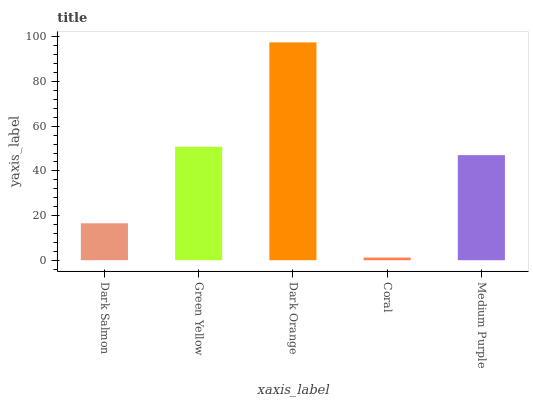Is Coral the minimum?
Answer yes or no. Yes. Is Dark Orange the maximum?
Answer yes or no. Yes. Is Green Yellow the minimum?
Answer yes or no. No. Is Green Yellow the maximum?
Answer yes or no. No. Is Green Yellow greater than Dark Salmon?
Answer yes or no. Yes. Is Dark Salmon less than Green Yellow?
Answer yes or no. Yes. Is Dark Salmon greater than Green Yellow?
Answer yes or no. No. Is Green Yellow less than Dark Salmon?
Answer yes or no. No. Is Medium Purple the high median?
Answer yes or no. Yes. Is Medium Purple the low median?
Answer yes or no. Yes. Is Dark Orange the high median?
Answer yes or no. No. Is Coral the low median?
Answer yes or no. No. 